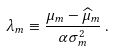Convert formula to latex. <formula><loc_0><loc_0><loc_500><loc_500>\lambda _ { m } \equiv \frac { \mu _ { m } - \widehat { \mu } _ { m } } { \alpha \sigma _ { m } ^ { 2 } } \, .</formula> 